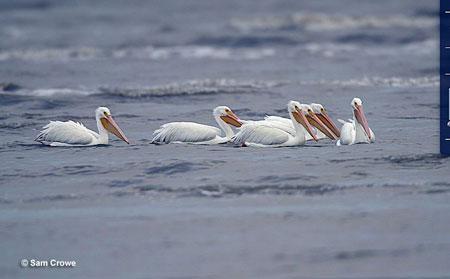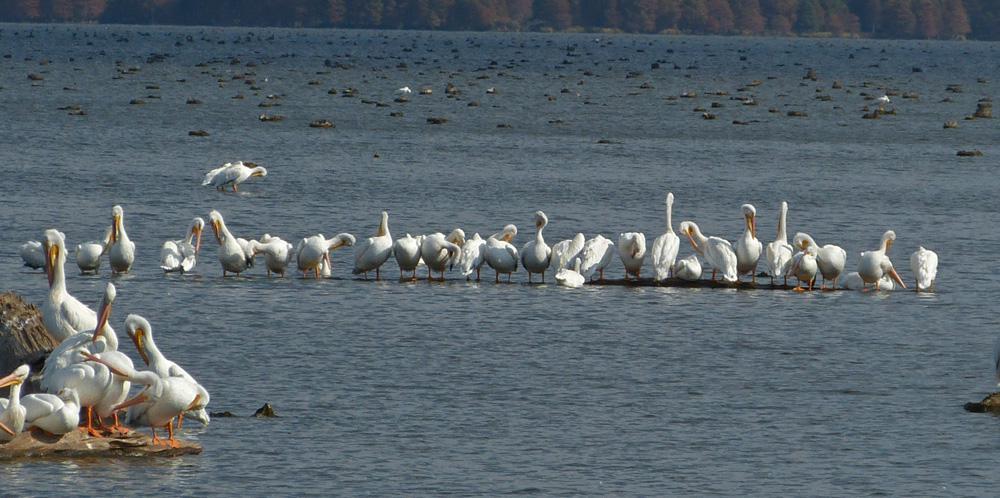The first image is the image on the left, the second image is the image on the right. Evaluate the accuracy of this statement regarding the images: "An expanse of sandbar is visible under the pelicans.". Is it true? Answer yes or no. No. 